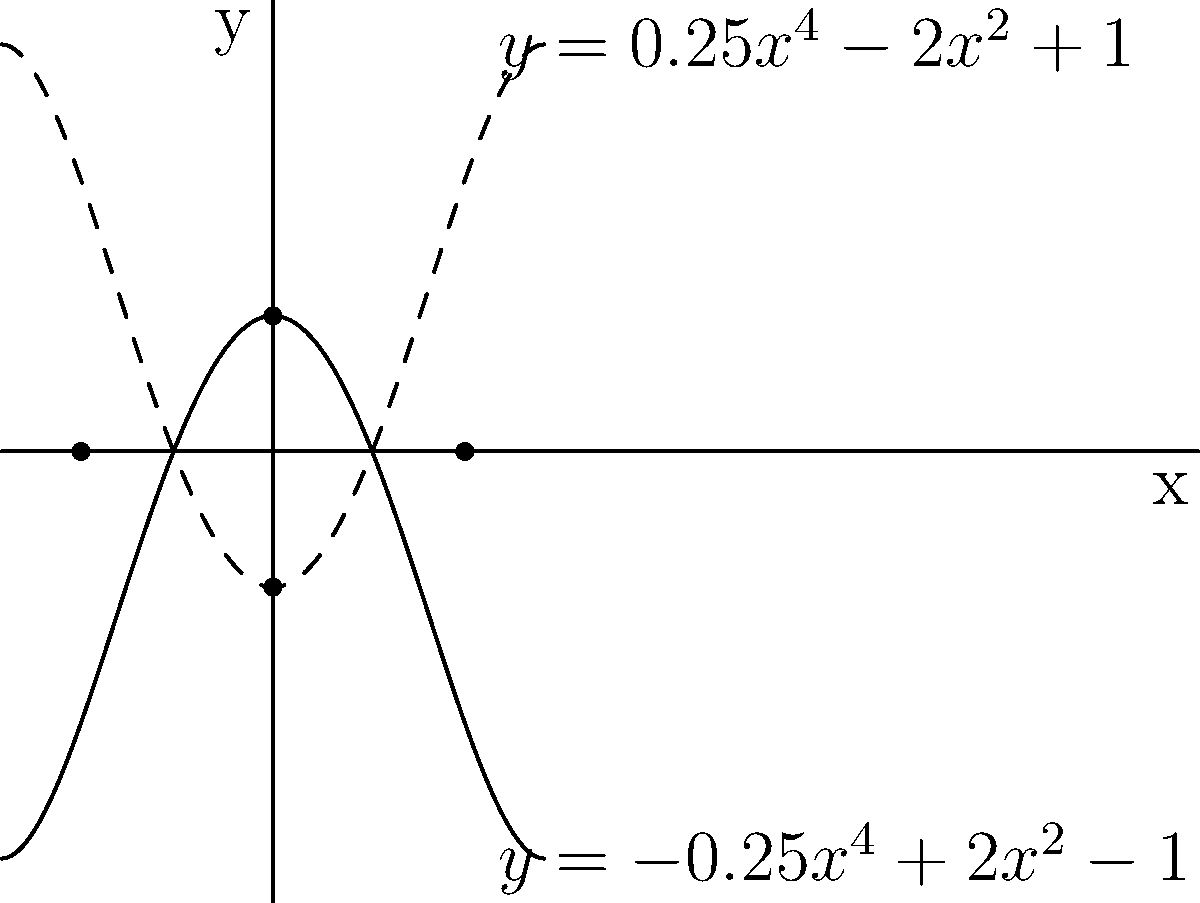The graph above represents a stylized version of the Batman logo. The solid line is given by the equation $y = 0.25x^4 - 2x^2 + 1$, and the dashed line by $y = -0.25x^4 + 2x^2 - 1$. What are the x-coordinates of the points where the two curves intersect? To find the intersection points, we need to solve the equation:

$0.25x^4 - 2x^2 + 1 = -0.25x^4 + 2x^2 - 1$

Step 1: Add $0.25x^4 - 2x^2 + 1$ to both sides:
$2(0.25x^4 - 2x^2 + 1) = 0$

Step 2: Simplify:
$0.5x^4 - 4x^2 + 2 = 0$

Step 3: Divide everything by 2:
$0.25x^4 - 2x^2 + 1 = 0$

Step 4: This is a quadratic equation in $x^2$. Let $u = x^2$:
$0.25u^2 - 2u + 1 = 0$

Step 5: Solve this quadratic equation:
$u = \frac{2 \pm \sqrt{4 - 4(0.25)(1)}}{2(0.25)} = \frac{2 \pm \sqrt{3}}{0.5} = 4 \pm 2\sqrt{3}$

Step 6: Substitute back $x^2 = u$:
$x^2 = 4 \pm 2\sqrt{3}$

Step 7: Take the square root of both sides:
$x = \pm\sqrt{4 \pm 2\sqrt{3}}$

Step 8: Simplify:
$x = \pm\sqrt{4 + 2\sqrt{3}}$ or $x = \pm\sqrt{4 - 2\sqrt{3}}$

Step 9: The second pair of solutions simplifies to $\pm\sqrt{2}$

Therefore, the x-coordinates of the intersection points are $\pm\sqrt{2}$.
Answer: $\pm\sqrt{2}$ 